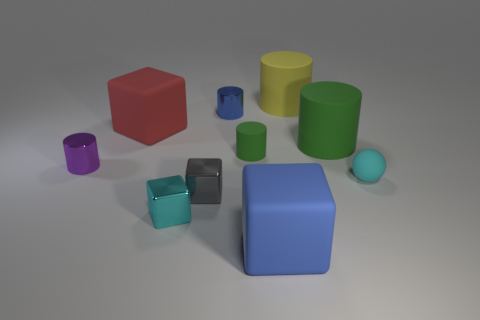Subtract all purple cylinders. How many cylinders are left? 4 Subtract all yellow cylinders. How many cylinders are left? 4 Subtract all gray cylinders. Subtract all brown cubes. How many cylinders are left? 5 Subtract all balls. How many objects are left? 9 Add 6 big yellow cylinders. How many big yellow cylinders exist? 7 Subtract 0 brown cylinders. How many objects are left? 10 Subtract all small rubber things. Subtract all tiny cyan rubber cubes. How many objects are left? 8 Add 2 cyan blocks. How many cyan blocks are left? 3 